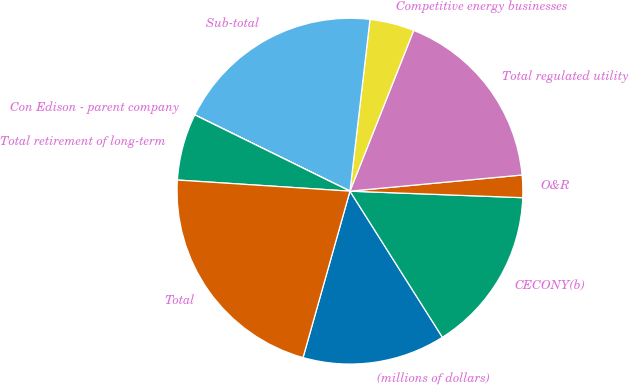<chart> <loc_0><loc_0><loc_500><loc_500><pie_chart><fcel>(millions of dollars)<fcel>CECONY(b)<fcel>O&R<fcel>Total regulated utility<fcel>Competitive energy businesses<fcel>Sub-total<fcel>Con Edison - parent company<fcel>Total retirement of long-term<fcel>Total<nl><fcel>13.35%<fcel>15.42%<fcel>2.09%<fcel>17.5%<fcel>4.16%<fcel>19.57%<fcel>0.01%<fcel>6.24%<fcel>21.65%<nl></chart> 